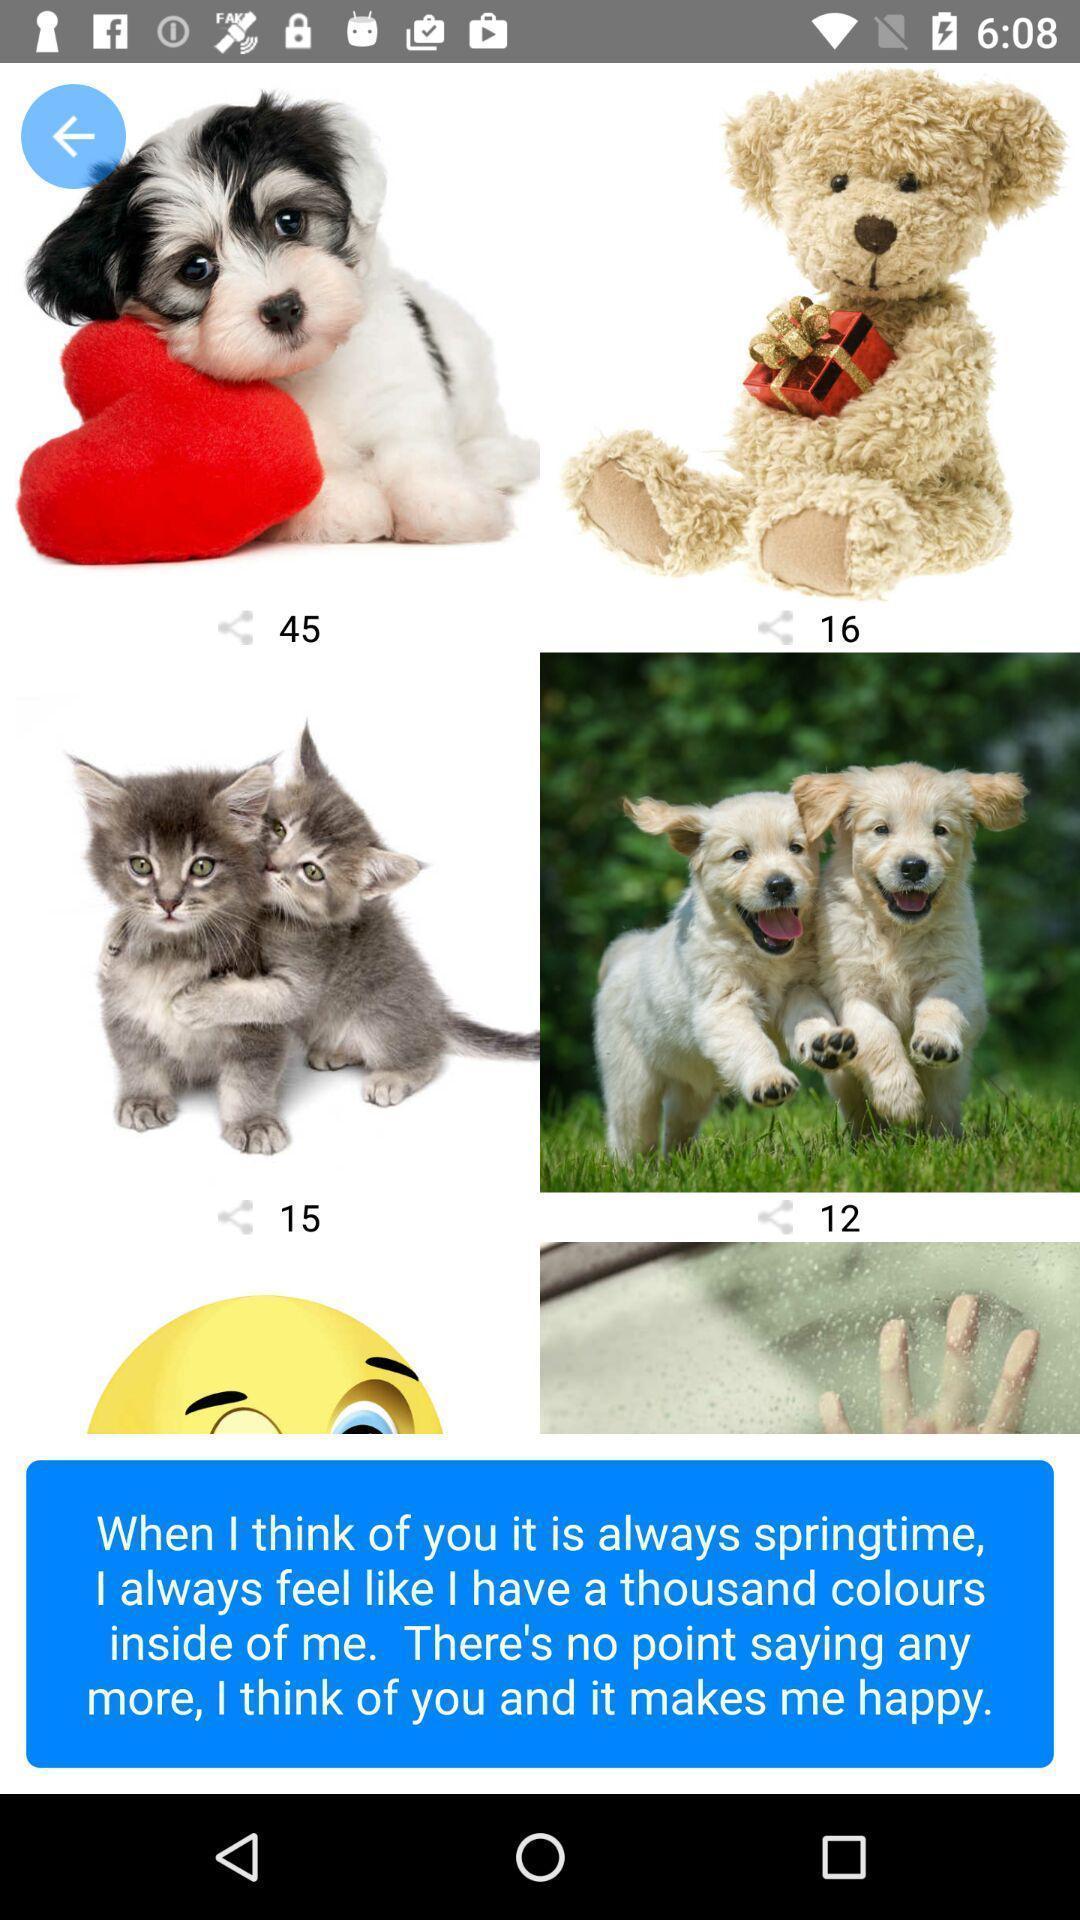What can you discern from this picture? Page showing different images on an app. 